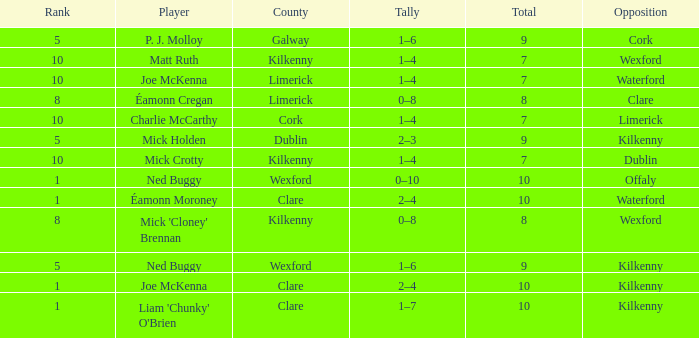Which County has a Rank larger than 8, and a Player of joe mckenna? Limerick. 